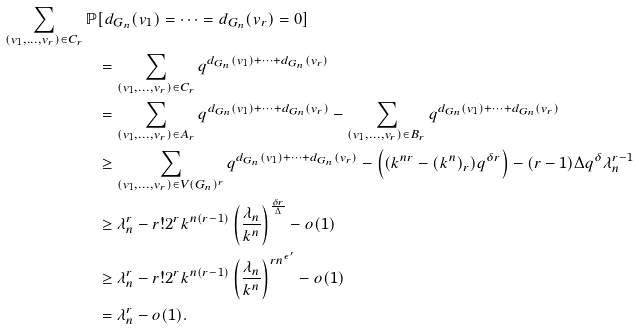Convert formula to latex. <formula><loc_0><loc_0><loc_500><loc_500>\sum _ { ( v _ { 1 } , \dots , v _ { r } ) \in C _ { r } } \mathbb { P } & [ d _ { G _ { n } } ( v _ { 1 } ) = \dots = d _ { G _ { n } } ( v _ { r } ) = 0 ] \\ & = \sum _ { ( v _ { 1 } , \dots , v _ { r } ) \in C _ { r } } q ^ { d _ { G _ { n } } ( v _ { 1 } ) + \dots + d _ { G _ { n } } ( v _ { r } ) } \\ & = \sum _ { ( v _ { 1 } , \dots , v _ { r } ) \in A _ { r } } q ^ { d _ { G _ { n } } ( v _ { 1 } ) + \dots + d _ { G _ { n } } ( v _ { r } ) } - \sum _ { ( v _ { 1 } , \dots , v _ { r } ) \in B _ { r } } q ^ { d _ { G _ { n } } ( v _ { 1 } ) + \dots + d _ { G _ { n } } ( v _ { r } ) } \\ & \geq \sum _ { ( v _ { 1 } , \dots , v _ { r } ) \in V ( G _ { n } ) ^ { r } } q ^ { d _ { G _ { n } } ( v _ { 1 } ) + \dots + d _ { G _ { n } } ( v _ { r } ) } - \left ( ( k ^ { n r } - ( k ^ { n } ) _ { r } ) q ^ { \delta r } \right ) - ( r - 1 ) \Delta q ^ { \delta } \lambda _ { n } ^ { r - 1 } \\ & \geq \lambda _ { n } ^ { r } - r ! 2 ^ { r } k ^ { n ( r - 1 ) } \left ( \frac { \lambda _ { n } } { k ^ { n } } \right ) ^ { \frac { \delta r } { \Delta } } - o ( 1 ) \\ & \geq \lambda _ { n } ^ { r } - r ! 2 ^ { r } k ^ { n ( r - 1 ) } \left ( \frac { \lambda _ { n } } { k ^ { n } } \right ) ^ { r n ^ { \epsilon ^ { \prime } } } - o ( 1 ) \\ & = \lambda ^ { r } _ { n } - o ( 1 ) .</formula> 